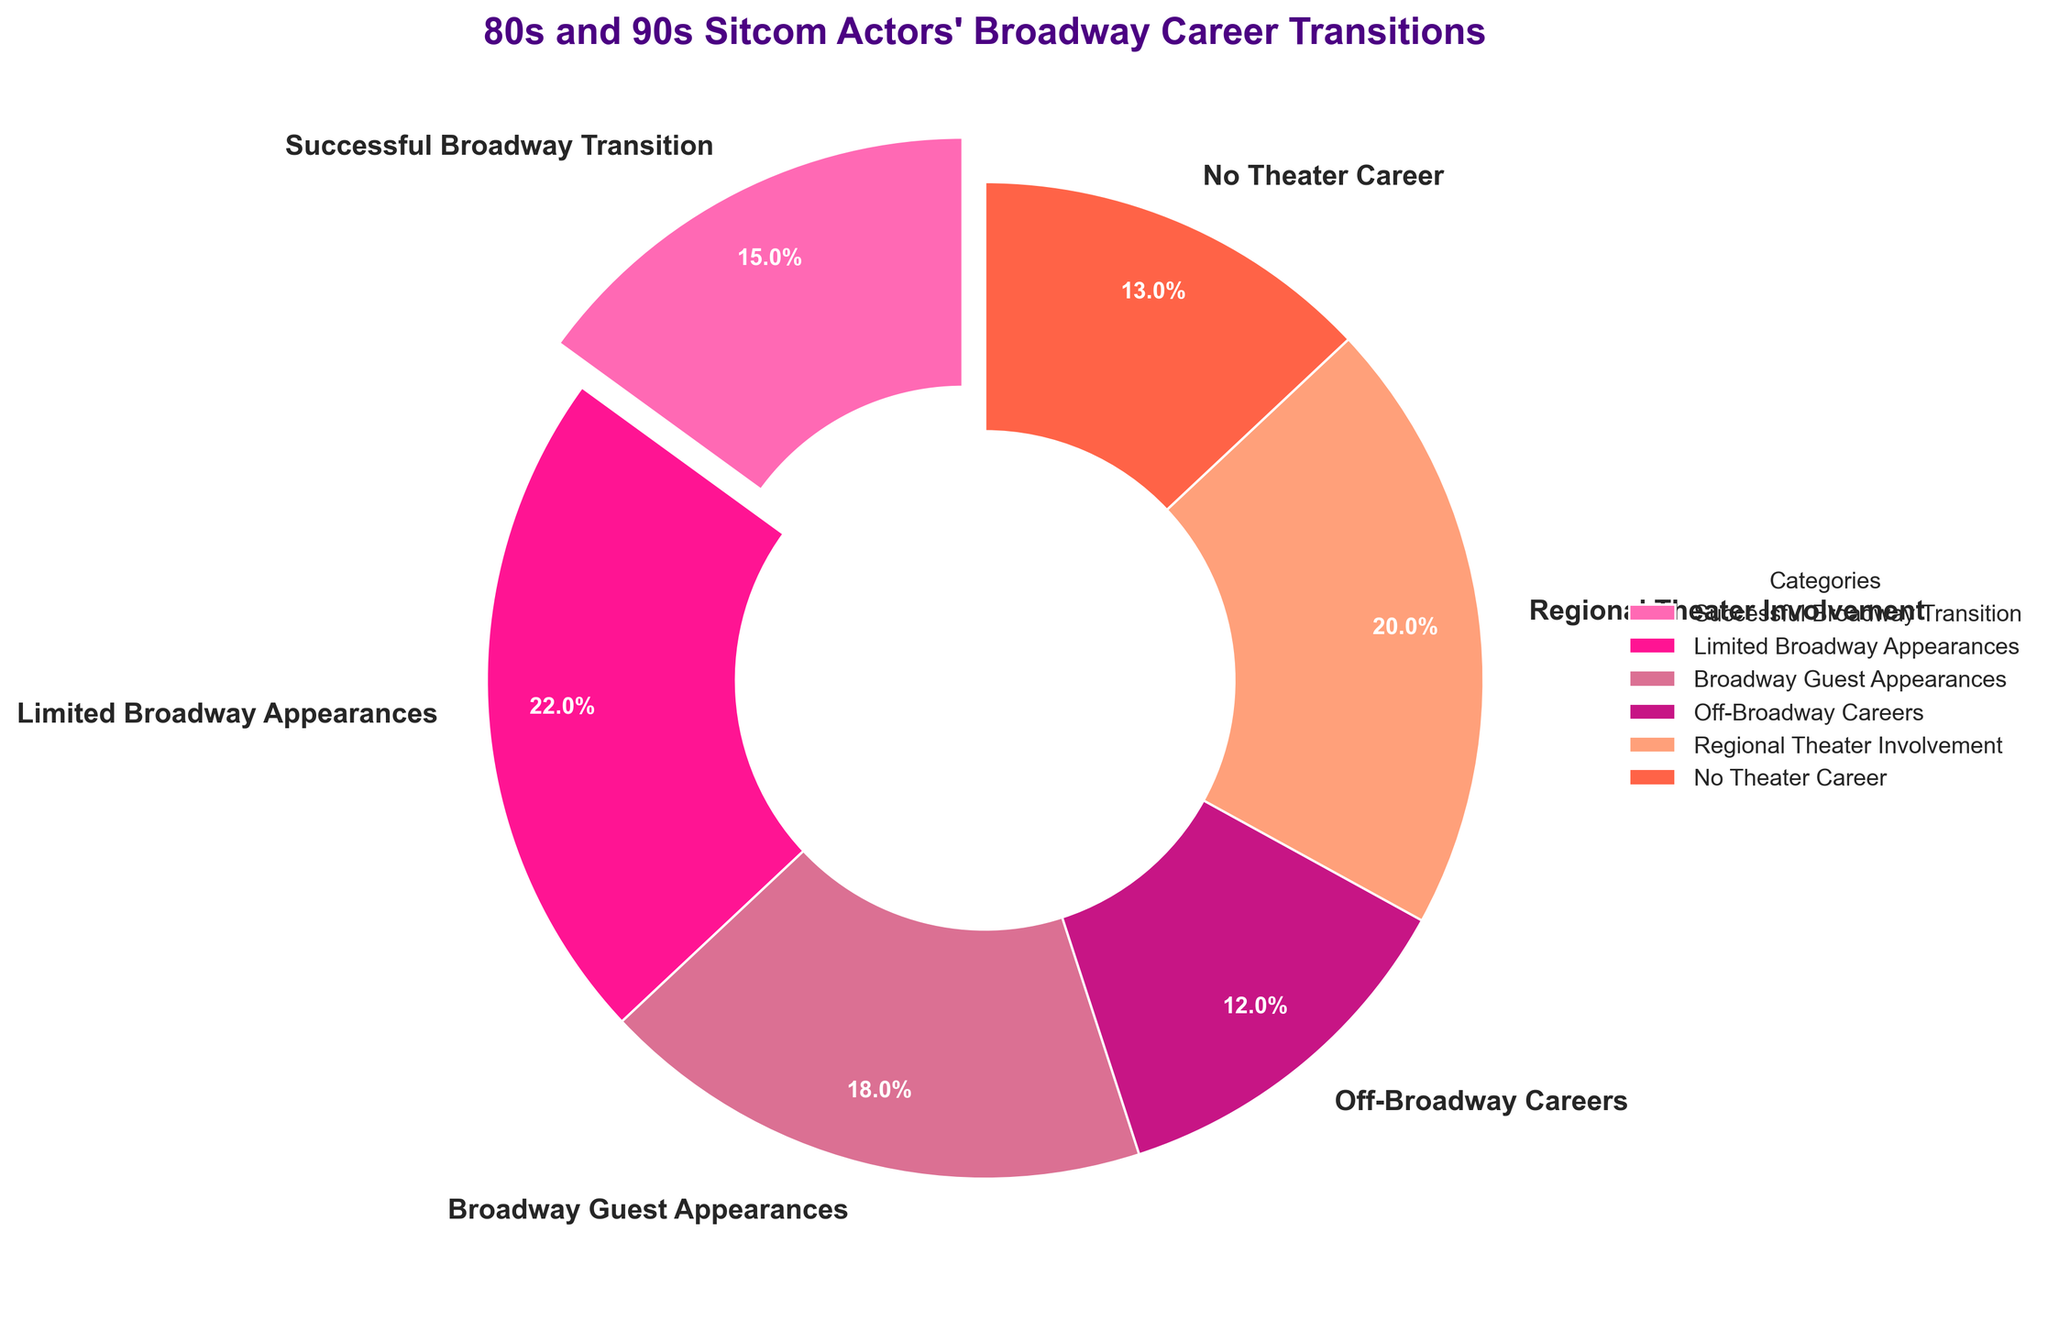Which category has the highest percentage of actors? "Limited Broadway Appearances" is the category with the highest percentage, as seen in the pie chart where its slice is the largest.
Answer: Limited Broadway Appearances What is the total percentage of actors who had either successful Broadway careers or limited Broadway appearances? Sum the percentages of "Successful Broadway Transition" and "Limited Broadway Appearances": 15% + 22% = 37%.
Answer: 37% Which category has a larger percentage, those with Broadway guest appearances or regional theater involvement? Compare the percentage of "Broadway Guest Appearances" (18%) with "Regional Theater Involvement" (20%). The latter is larger.
Answer: Regional Theater Involvement What is the percentage difference between actors who never had a theater career and those involved in regional theater? Subtract the percentage of "No Theater Career" from "Regional Theater Involvement": 20% - 13% = 7%.
Answer: 7% Which color represents the category with the smallest percentage, and what is that category? The pie chart shows the smallest slice in orange, which corresponds to the "Off-Broadway Careers" category at 12%.
Answer: Orange, Off-Broadway Careers How many total categories are depicted in the pie chart? By counting the number of distinct slices or segments in the pie chart, we see there are 6 categories.
Answer: 6 Are there more actors with successful Broadway transitions or those who had no theater career at all? Compare "Successful Broadway Transition" (15%) and "No Theater Career" (13%). There are more actors with successful Broadway transitions.
Answer: Successful Broadway Transition If you combine the percentages of those involved in regional theater and those with off-Broadway careers, what portion of the chart does this represent? Sum the percentages of "Regional Theater Involvement" (20%) and "Off-Broadway Careers" (12%): 20% + 12% = 32%.
Answer: 32% Which segment has a slice that is expanded or "exploded" for emphasis on the pie chart? The slice for "Successful Broadway Transition" is exploded outwards for emphasis.
Answer: Successful Broadway Transition What percentage of actors had some form of Broadway appearance (either successful, limited, or guest)? Add the percentages of "Successful Broadway Transition," "Limited Broadway Appearances," and "Broadway Guest Appearances": 15% + 22% + 18% = 55%.
Answer: 55% 